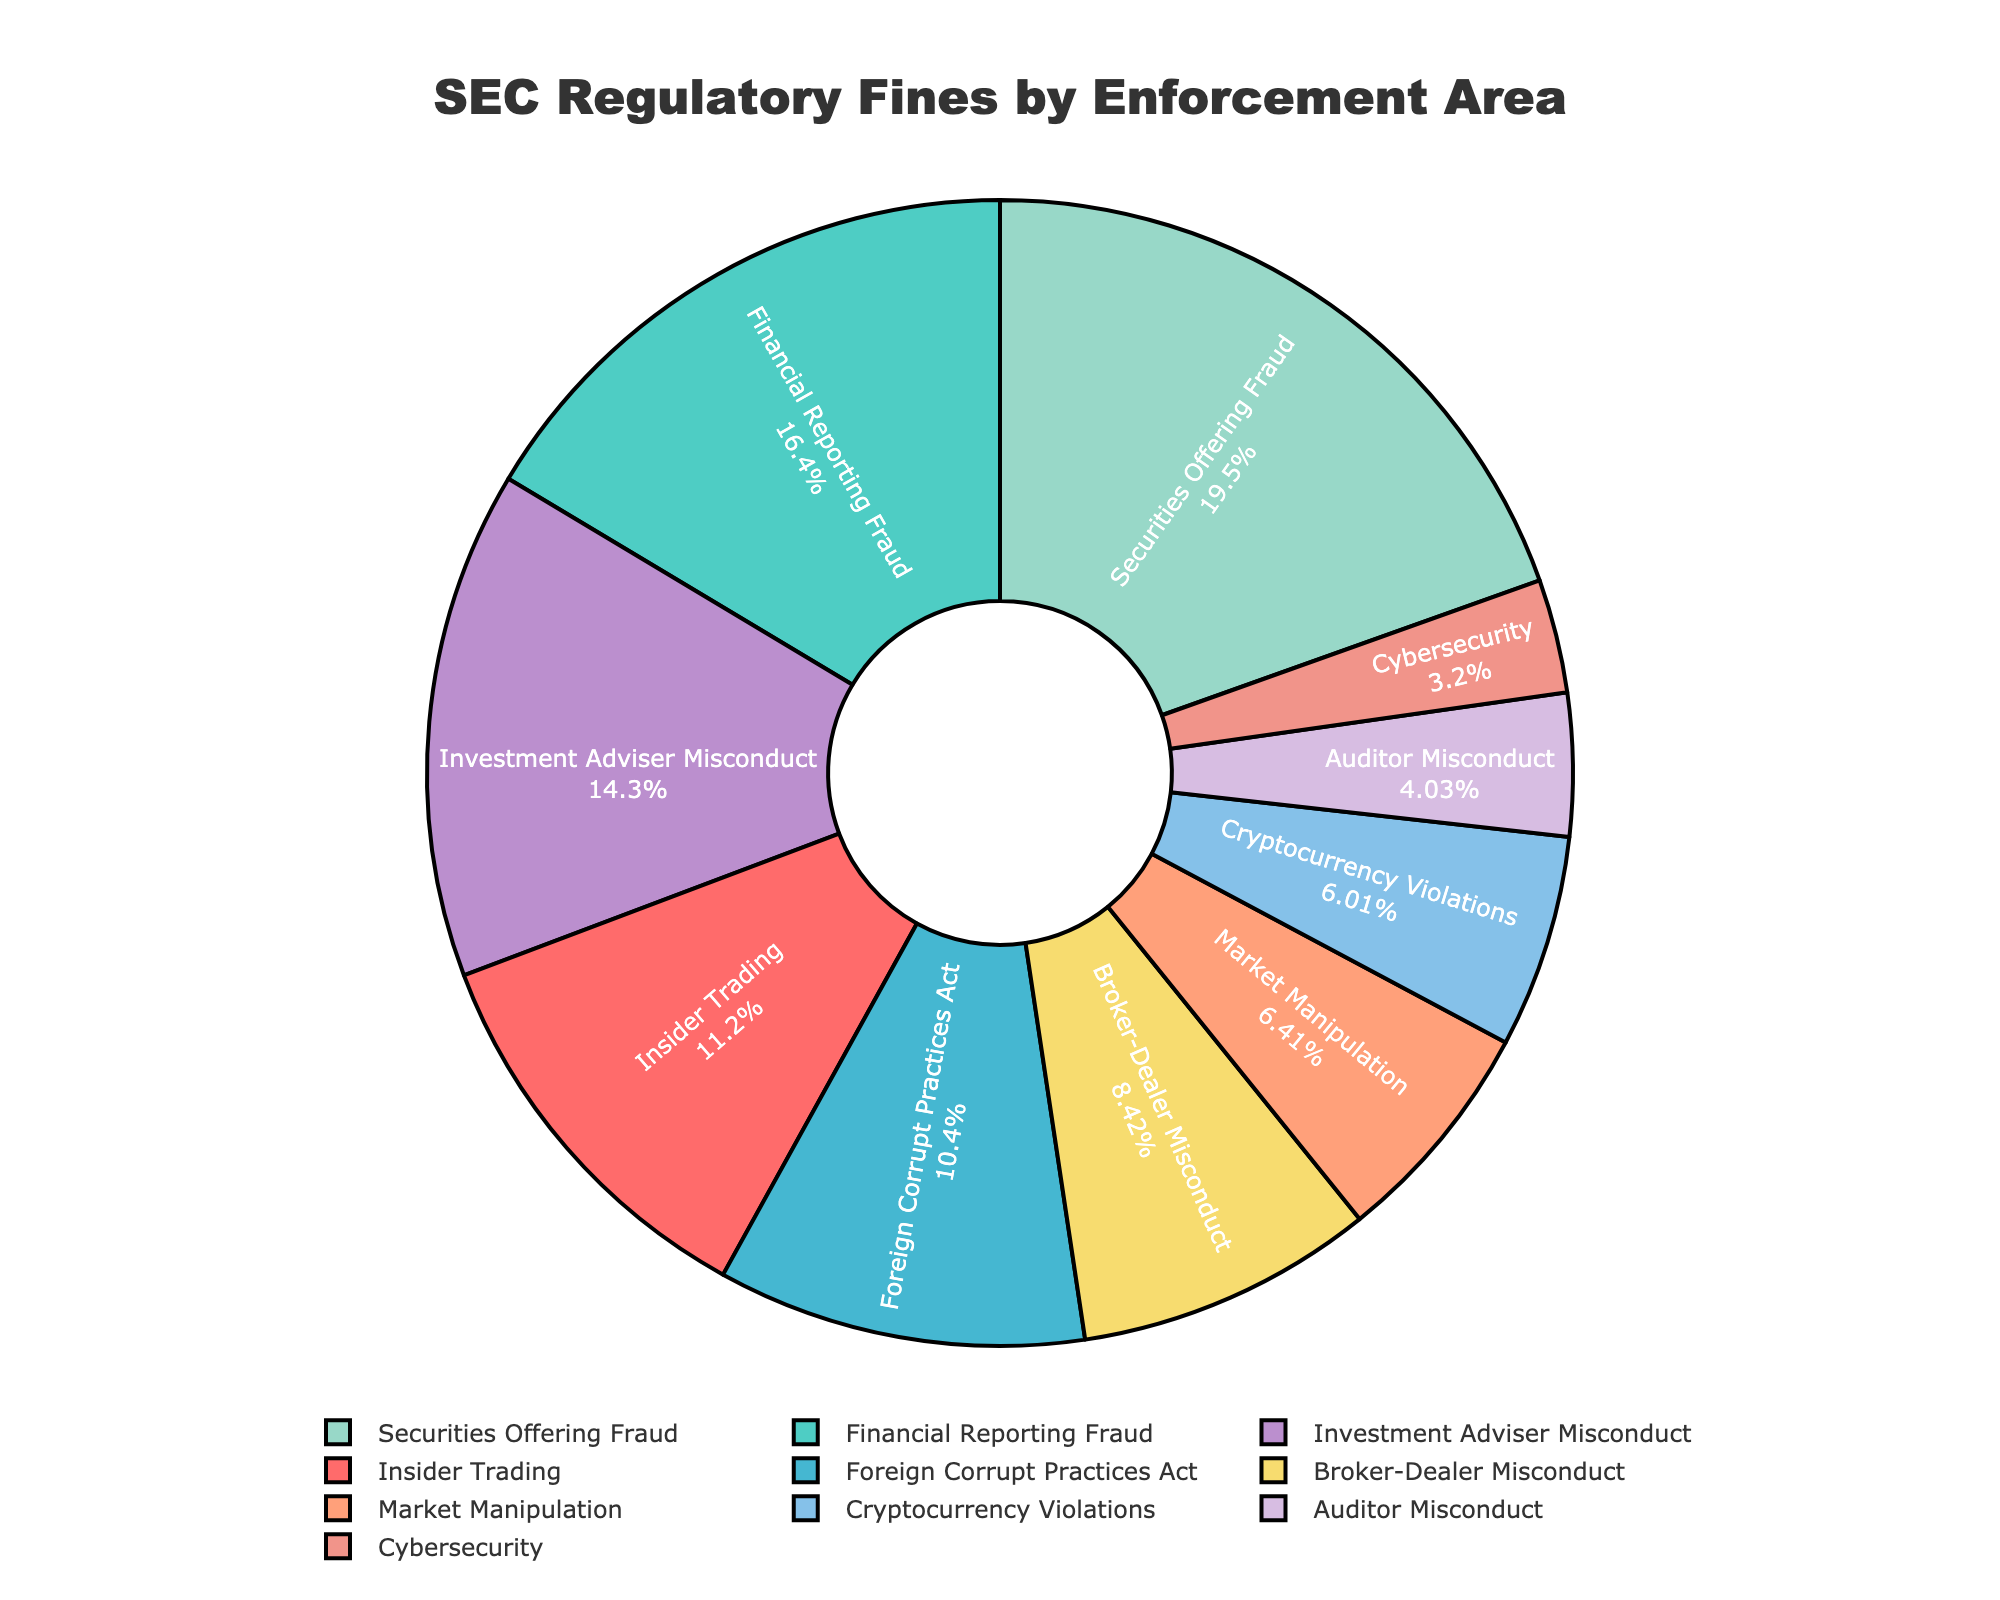What percent of the fines are attributed to Securities Offering Fraud? To find the percent of fines attributed to Securities Offering Fraud, look at the section of the pie chart labeled "Securities Offering Fraud" and note the percentage displayed inside the segment.
Answer: 21% Which enforcement area has the smallest allocation of regulatory fines? Look at the segments of the pie chart and identify the smallest segment by its size, which corresponds to the smallest allocation of fines.
Answer: Cybersecurity What is the difference in fine amounts between Financial Reporting Fraud and Insider Trading? Identify the fine amounts for Financial Reporting Fraud ($456 million) and Insider Trading ($312 million) from the segments. Then subtract the smaller from the larger amount: $456 million - $312 million.
Answer: $144 million How much more in fines does Broker-Dealer Misconduct receive compared to Cybersecurity? Note the fine amounts for Broker-Dealer Misconduct ($234 million) and Cybersecurity ($89 million). Subtract the smaller value from the larger value: $234 million - $89 million.
Answer: $145 million Which enforcement areas have more than 10% of the total fines? Identify all segments that display a percentage of more than 10% from the pie chart.
Answer: Insider Trading, Financial Reporting Fraud, Securities Offering Fraud, Investment Adviser Misconduct What is the total percentage of fines attributed to Market Manipulation and Cryptocurrency Violations combined? Look at the percentages for Market Manipulation and Cryptocurrency Violations in the pie chart, then add these two values together.
Answer: 7% + 6% = 13% Which enforcement area receives greater fines, Broker-Dealer Misconduct or Investment Adviser Misconduct? Compare the fine amounts labeled for Broker-Dealer Misconduct ($234 million) and Investment Adviser Misconduct ($398 million) in the pie chart.
Answer: Investment Adviser Misconduct What color represents Financial Reporting Fraud in the chart? Identify the segment labeled "Financial Reporting Fraud" and describe its color.
Answer: Green (or according to the specific color used in the palette mentioned for Financial Reporting Fraud) Is the fine amount for Auditor Misconduct greater or less than for Foreign Corrupt Practices Act? Compare the fine amounts given by the segments for Auditor Misconduct ($112 million) and Foreign Corrupt Practices Act ($289 million).
Answer: Less 